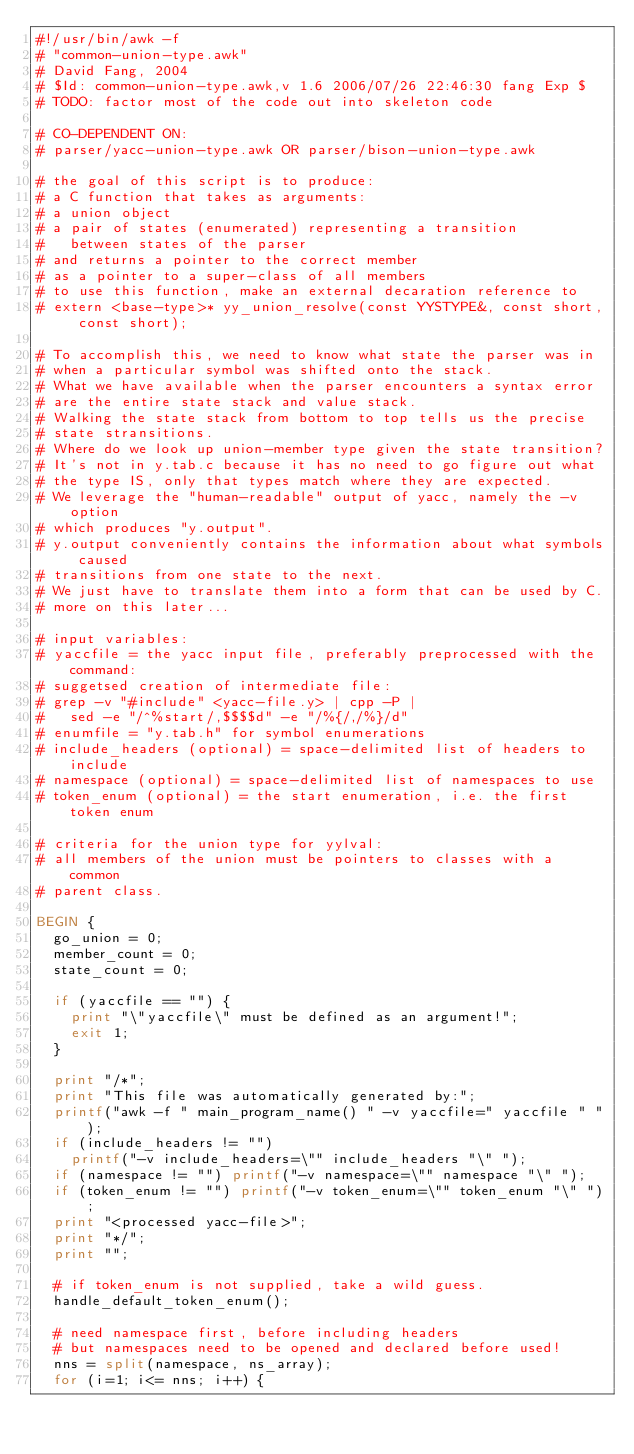Convert code to text. <code><loc_0><loc_0><loc_500><loc_500><_Awk_>#!/usr/bin/awk -f
# "common-union-type.awk"
# David Fang, 2004
#	$Id: common-union-type.awk,v 1.6 2006/07/26 22:46:30 fang Exp $
# TODO: factor most of the code out into skeleton code

# CO-DEPENDENT ON:
# parser/yacc-union-type.awk OR parser/bison-union-type.awk

# the goal of this script is to produce:
# a C function that takes as arguments:
#	a union object
#	a pair of states (enumerated) representing a transition
#		between states of the parser
# and returns a pointer to the correct member
#	as a pointer to a super-class of all members
# to use this function, make an external decaration reference to
# extern <base-type>* yy_union_resolve(const YYSTYPE&, const short, const short);

# To accomplish this, we need to know what state the parser was in
# when a particular symbol was shifted onto the stack.  
# What we have available when the parser encounters a syntax error
# are the entire state stack and value stack.  
# Walking the state stack from bottom to top tells us the precise
# state stransitions.  
# Where do we look up union-member type given the state transition?
# It's not in y.tab.c because it has no need to go figure out what
# the type IS, only that types match where they are expected.  
# We leverage the "human-readable" output of yacc, namely the -v option
# which produces "y.output".  
# y.output conveniently contains the information about what symbols caused
# transitions from one state to the next.  
# We just have to translate them into a form that can be used by C.  
# more on this later...

# input variables:
# yaccfile = the yacc input file, preferably preprocessed with the command:
#	suggetsed creation of intermediate file:
#	grep -v "#include" <yacc-file.y> | cpp -P |
#		sed -e "/^%start/,$$$$d" -e "/%{/,/%}/d"
# enumfile = "y.tab.h" for symbol enumerations
# include_headers (optional) = space-delimited list of headers to include
# namespace (optional) = space-delimited list of namespaces to use
# token_enum (optional) = the start enumeration, i.e. the first token enum

# criteria for the union type for yylval:
# all members of the union must be pointers to classes with a common
# parent class.  

BEGIN {
	go_union = 0;
	member_count = 0;
	state_count = 0;

	if (yaccfile == "") {
		print "\"yaccfile\" must be defined as an argument!";
		exit 1;
	} 

	print "/*";
	print "This file was automatically generated by:";
	printf("awk -f " main_program_name() " -v yaccfile=" yaccfile " ");
	if (include_headers != "")
		printf("-v include_headers=\"" include_headers "\" ");
	if (namespace != "") printf("-v namespace=\"" namespace "\" ");
	if (token_enum != "") printf("-v token_enum=\"" token_enum "\" ");
	print "<processed yacc-file>";
	print "*/";
	print "";

	# if token_enum is not supplied, take a wild guess.
	handle_default_token_enum();

	# need namespace first, before including headers
	# but namespaces need to be opened and declared before used!
	nns = split(namespace, ns_array);
	for (i=1; i<= nns; i++) {</code> 